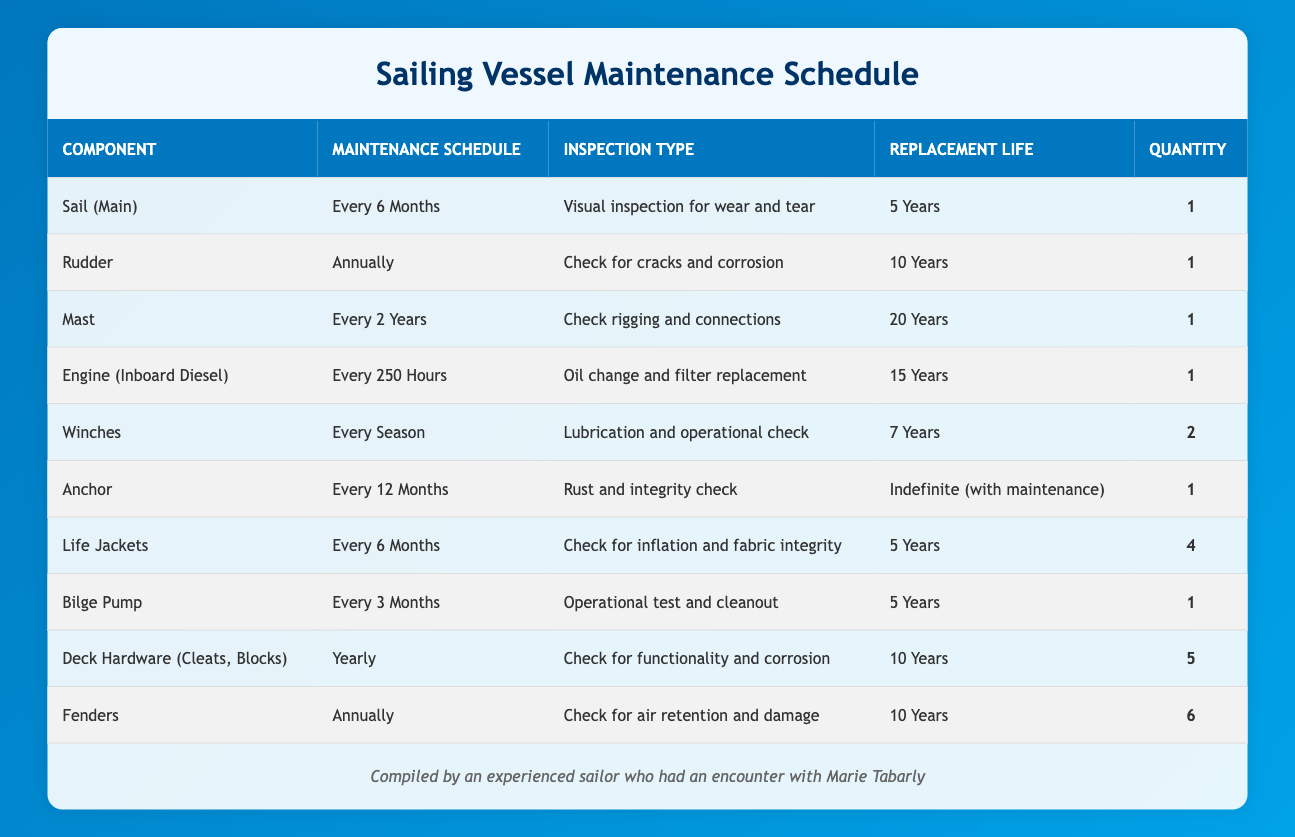What is the replacement life of the Rudder? The table lists the "Replacement Life" for each component. For the Rudder, it specifically states "10 Years."
Answer: 10 Years How often should the Bilge Pump be maintained? The "Maintenance Schedule" column indicates that the Bilge Pump should be maintained "Every 3 Months."
Answer: Every 3 Months How many Life Jackets are in the inventory? The "Quantity" column for Life Jackets shows there are 4 units listed.
Answer: 4 Which component requires a maintenance schedule more frequently, the Winches or the Sail (Main)? The Winches have a maintenance schedule of "Every Season," while the Sail (Main) is maintained "Every 6 Months." Since "Every Season" generally implies a time frame of up to 4 months, the Sail (Main) is maintained more frequently.
Answer: Sail (Main) What is the total number of components that need to be replaced within 5 years? To find components with a replacement life of 5 years, check the "Replacement Life" for each component. The Sail (Main), Life Jackets, and Bilge Pump fall under this category. Adding them gives us a total of 3 components.
Answer: 3 Is it true that the Anchor has an indefinite replacement life? The "Replacement Life" for the Anchor indeed states "Indefinite (with maintenance)," confirming that this is true.
Answer: Yes How many components are inspected annually? The components that require annual inspections are the Rudder, Fenders, and Deck Hardware. This totals 3 components that are checked every year.
Answer: 3 Calculate the average replacement life of the components listed with a 10-year lifespan. The components with a 10-year replacement life are the Rudder, Deck Hardware, and Fenders. Sum their replacement lives: 10 + 10 + 10 = 30 years. Then divide by the number of components (3): 30/3 = 10 years.
Answer: 10 years Which component has the longest replacement life? The Mast has the longest replacement life listed at "20 Years." By reviewing the table, we can see no other component surpasses this lifespan.
Answer: 20 Years 